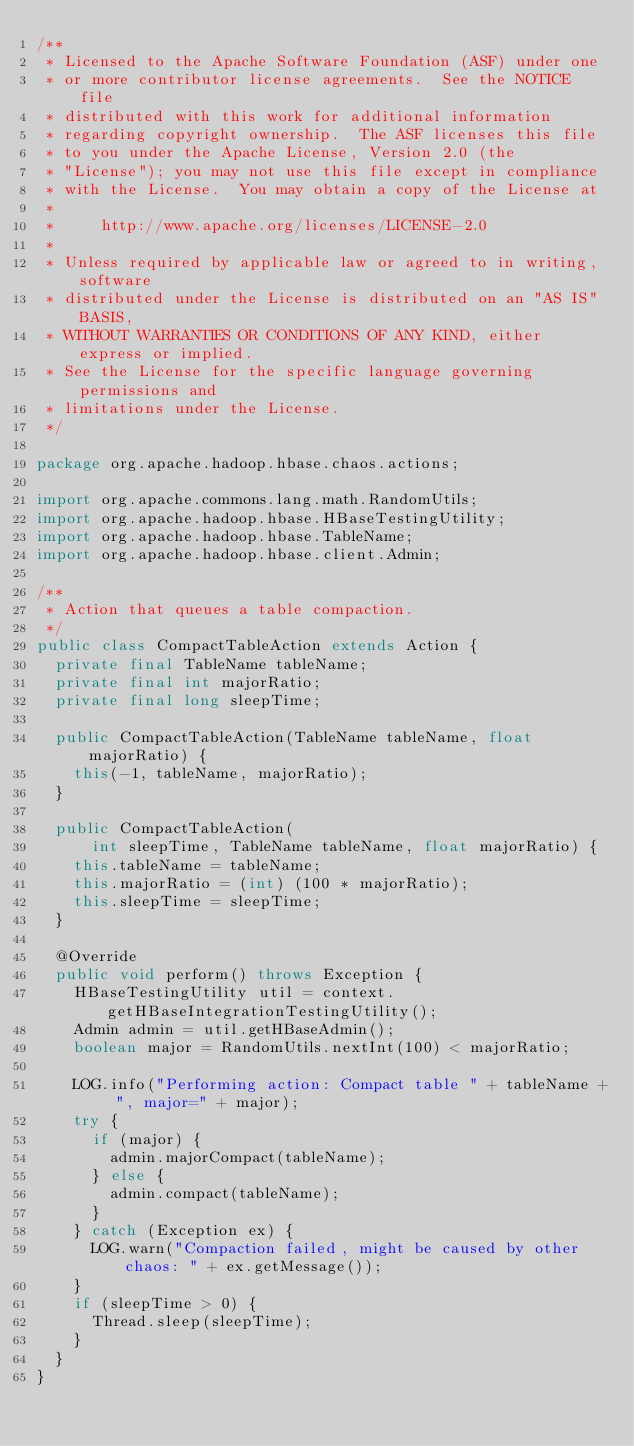<code> <loc_0><loc_0><loc_500><loc_500><_Java_>/**
 * Licensed to the Apache Software Foundation (ASF) under one
 * or more contributor license agreements.  See the NOTICE file
 * distributed with this work for additional information
 * regarding copyright ownership.  The ASF licenses this file
 * to you under the Apache License, Version 2.0 (the
 * "License"); you may not use this file except in compliance
 * with the License.  You may obtain a copy of the License at
 *
 *     http://www.apache.org/licenses/LICENSE-2.0
 *
 * Unless required by applicable law or agreed to in writing, software
 * distributed under the License is distributed on an "AS IS" BASIS,
 * WITHOUT WARRANTIES OR CONDITIONS OF ANY KIND, either express or implied.
 * See the License for the specific language governing permissions and
 * limitations under the License.
 */

package org.apache.hadoop.hbase.chaos.actions;

import org.apache.commons.lang.math.RandomUtils;
import org.apache.hadoop.hbase.HBaseTestingUtility;
import org.apache.hadoop.hbase.TableName;
import org.apache.hadoop.hbase.client.Admin;

/**
 * Action that queues a table compaction.
 */
public class CompactTableAction extends Action {
  private final TableName tableName;
  private final int majorRatio;
  private final long sleepTime;

  public CompactTableAction(TableName tableName, float majorRatio) {
    this(-1, tableName, majorRatio);
  }

  public CompactTableAction(
      int sleepTime, TableName tableName, float majorRatio) {
    this.tableName = tableName;
    this.majorRatio = (int) (100 * majorRatio);
    this.sleepTime = sleepTime;
  }

  @Override
  public void perform() throws Exception {
    HBaseTestingUtility util = context.getHBaseIntegrationTestingUtility();
    Admin admin = util.getHBaseAdmin();
    boolean major = RandomUtils.nextInt(100) < majorRatio;

    LOG.info("Performing action: Compact table " + tableName + ", major=" + major);
    try {
      if (major) {
        admin.majorCompact(tableName);
      } else {
        admin.compact(tableName);
      }
    } catch (Exception ex) {
      LOG.warn("Compaction failed, might be caused by other chaos: " + ex.getMessage());
    }
    if (sleepTime > 0) {
      Thread.sleep(sleepTime);
    }
  }
}
</code> 